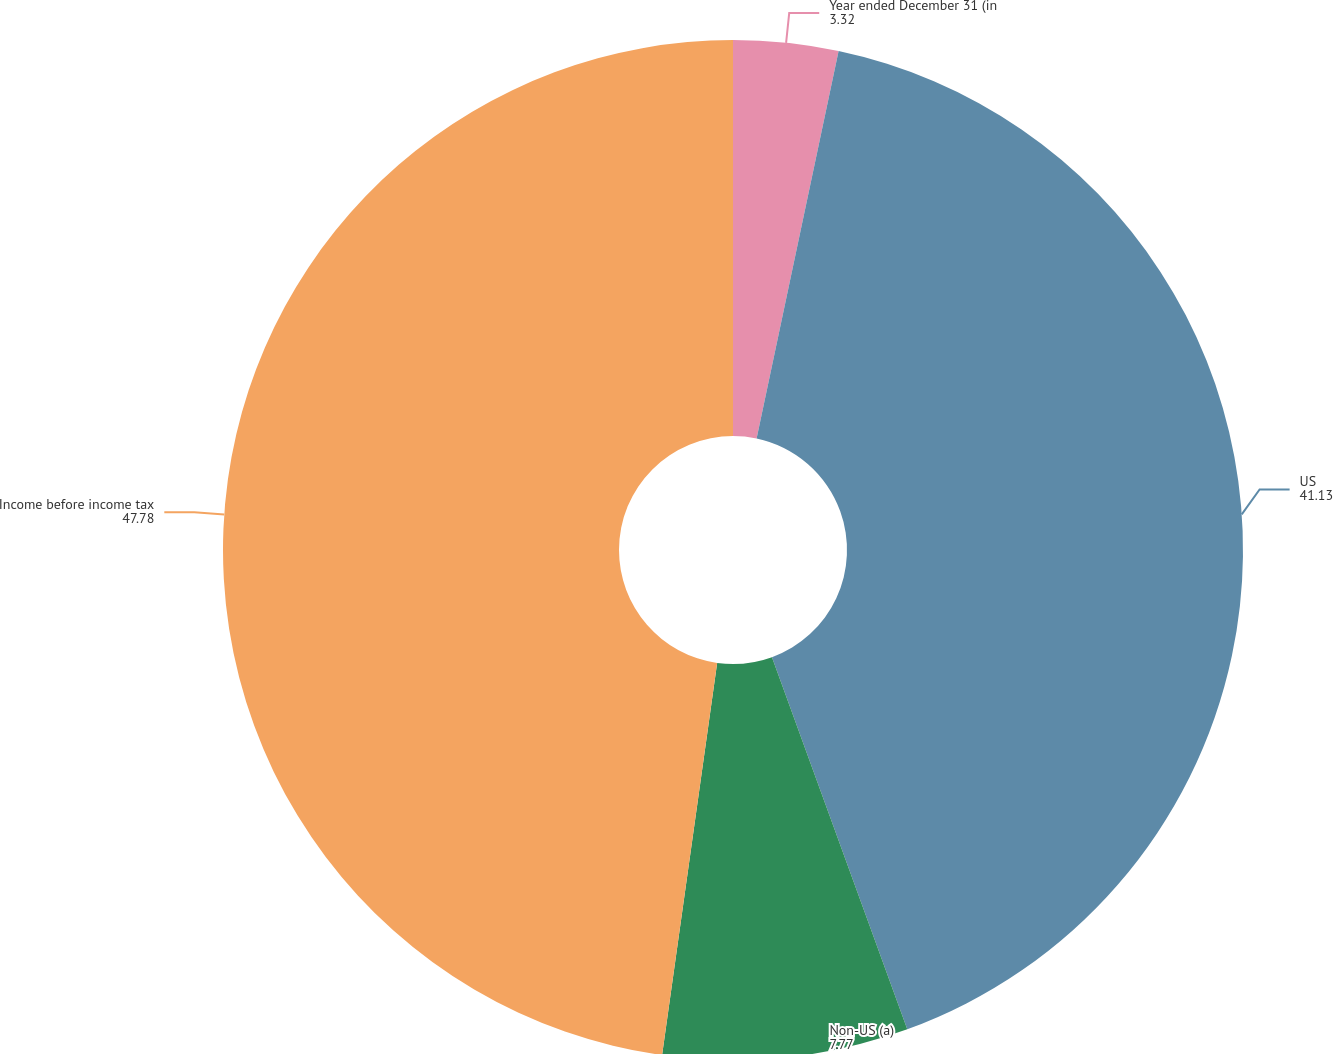<chart> <loc_0><loc_0><loc_500><loc_500><pie_chart><fcel>Year ended December 31 (in<fcel>US<fcel>Non-US (a)<fcel>Income before income tax<nl><fcel>3.32%<fcel>41.13%<fcel>7.77%<fcel>47.78%<nl></chart> 